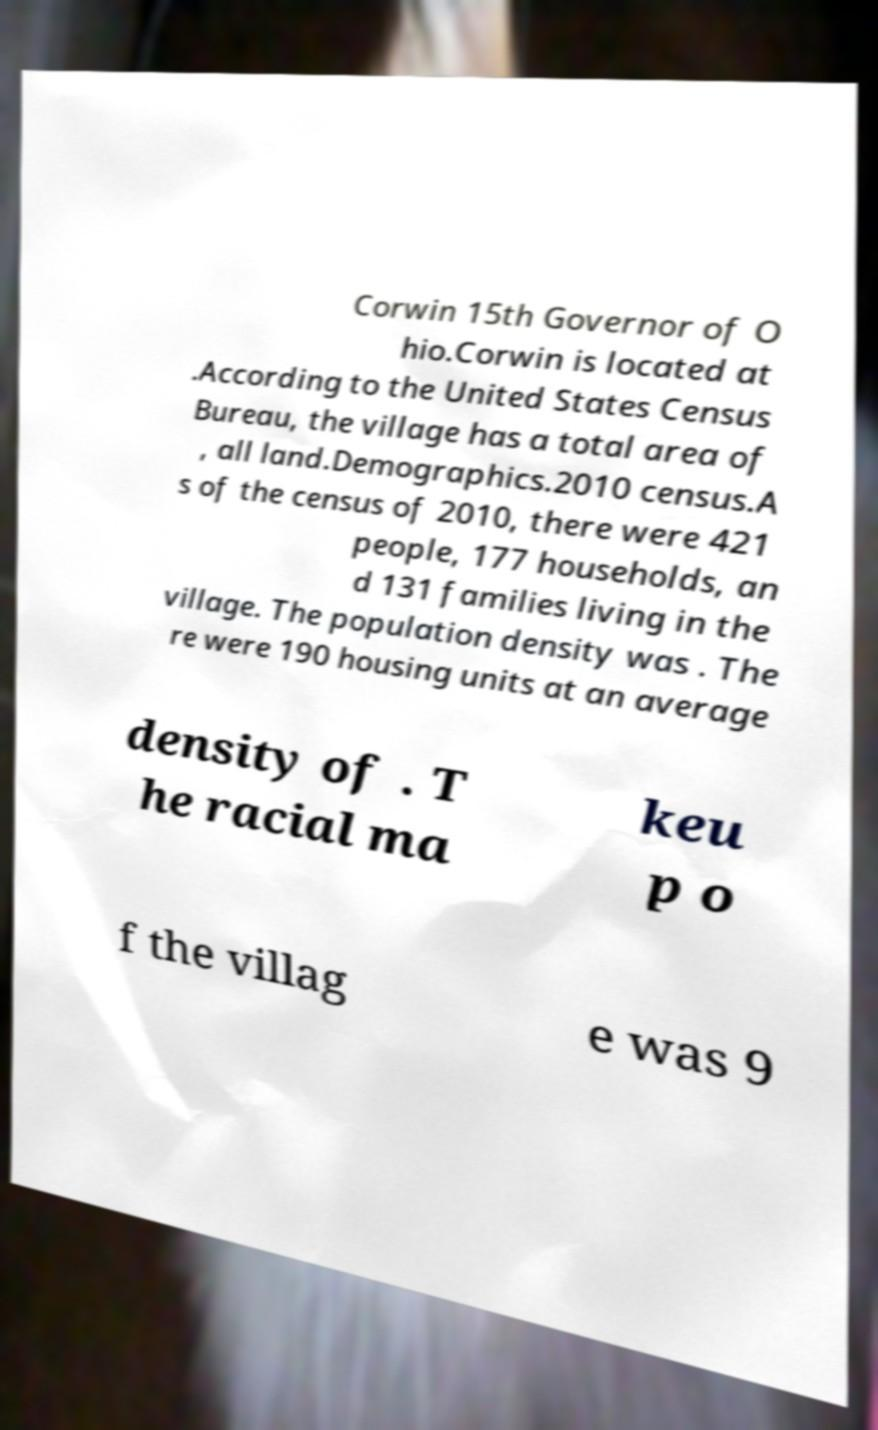Could you assist in decoding the text presented in this image and type it out clearly? Corwin 15th Governor of O hio.Corwin is located at .According to the United States Census Bureau, the village has a total area of , all land.Demographics.2010 census.A s of the census of 2010, there were 421 people, 177 households, an d 131 families living in the village. The population density was . The re were 190 housing units at an average density of . T he racial ma keu p o f the villag e was 9 